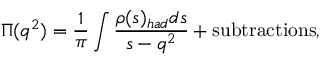<formula> <loc_0><loc_0><loc_500><loc_500>\Pi ( q ^ { 2 } ) = \frac { 1 } { \pi } \int \frac { \rho ( s ) _ { h a d } d s } { s - q ^ { 2 } } + s u b t r a c t i o n s ,</formula> 